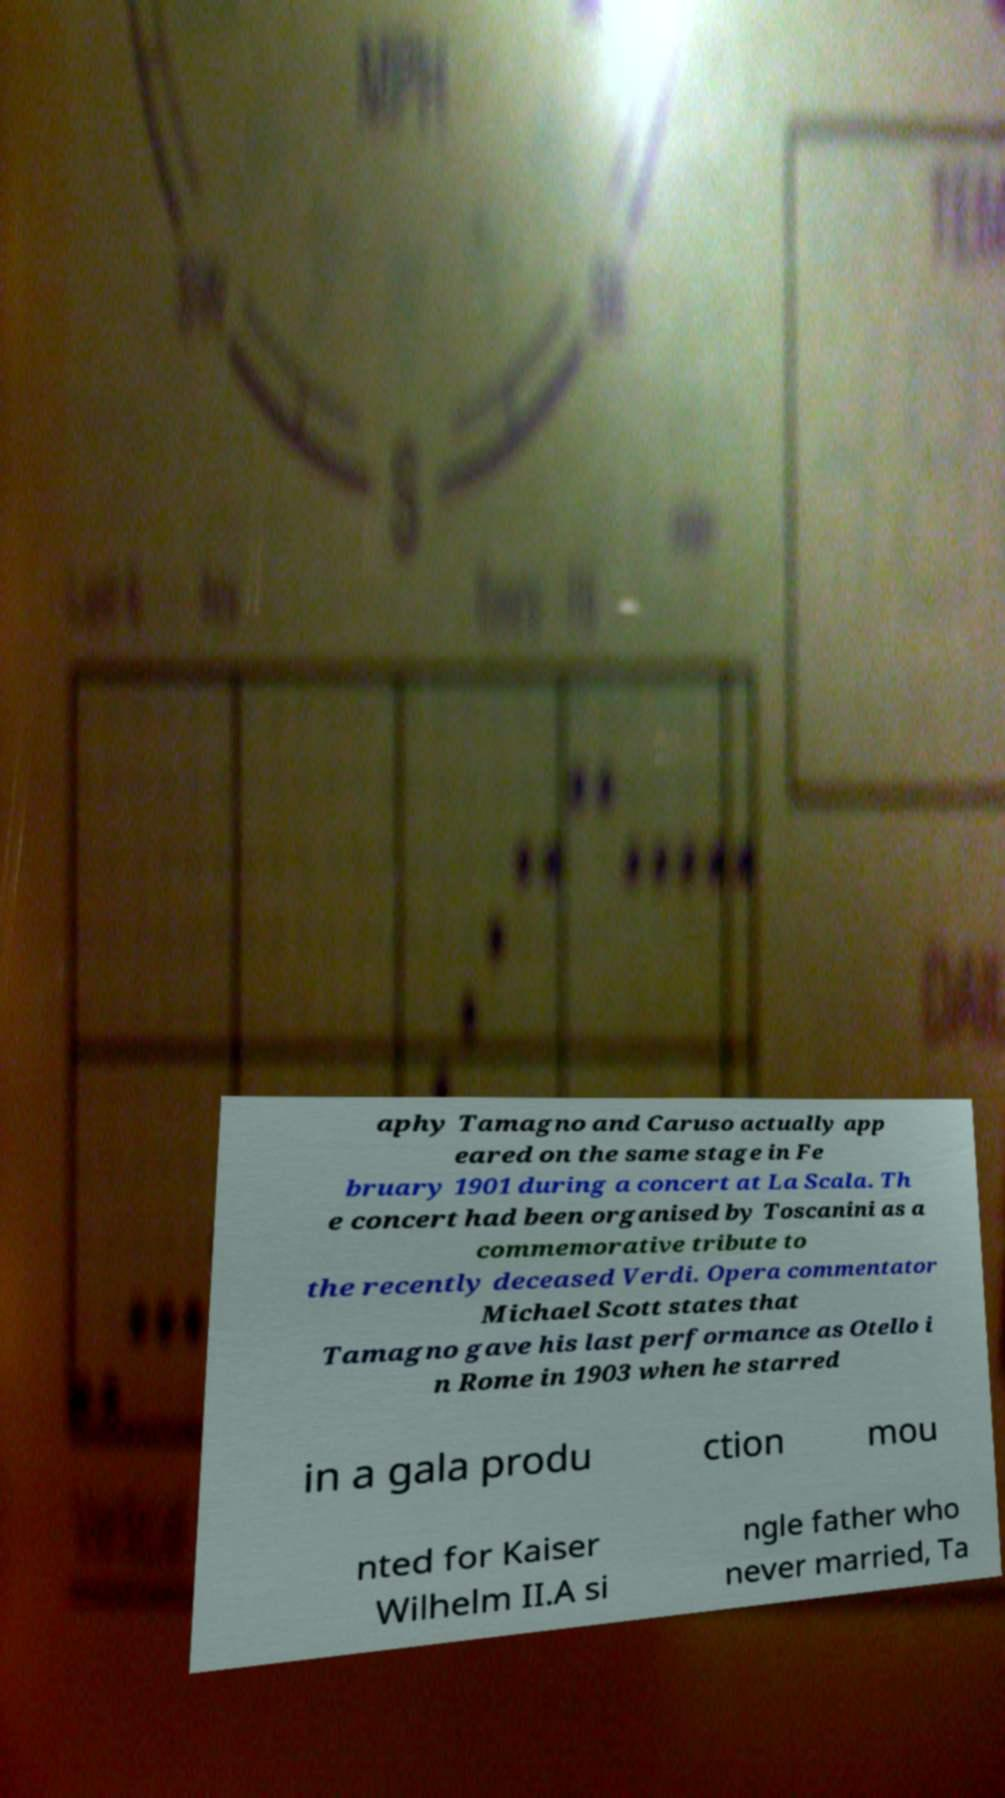What messages or text are displayed in this image? I need them in a readable, typed format. aphy Tamagno and Caruso actually app eared on the same stage in Fe bruary 1901 during a concert at La Scala. Th e concert had been organised by Toscanini as a commemorative tribute to the recently deceased Verdi. Opera commentator Michael Scott states that Tamagno gave his last performance as Otello i n Rome in 1903 when he starred in a gala produ ction mou nted for Kaiser Wilhelm II.A si ngle father who never married, Ta 